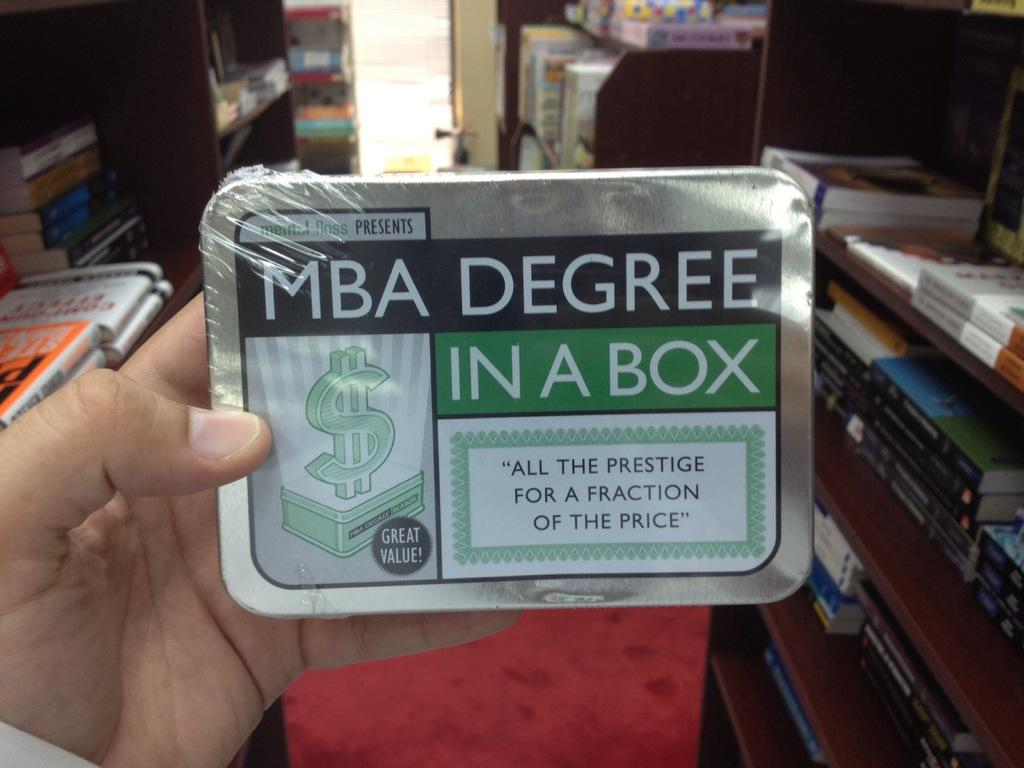<image>
Write a terse but informative summary of the picture. A shrink wrapped box contains a product named MBA Degree in a Box. 